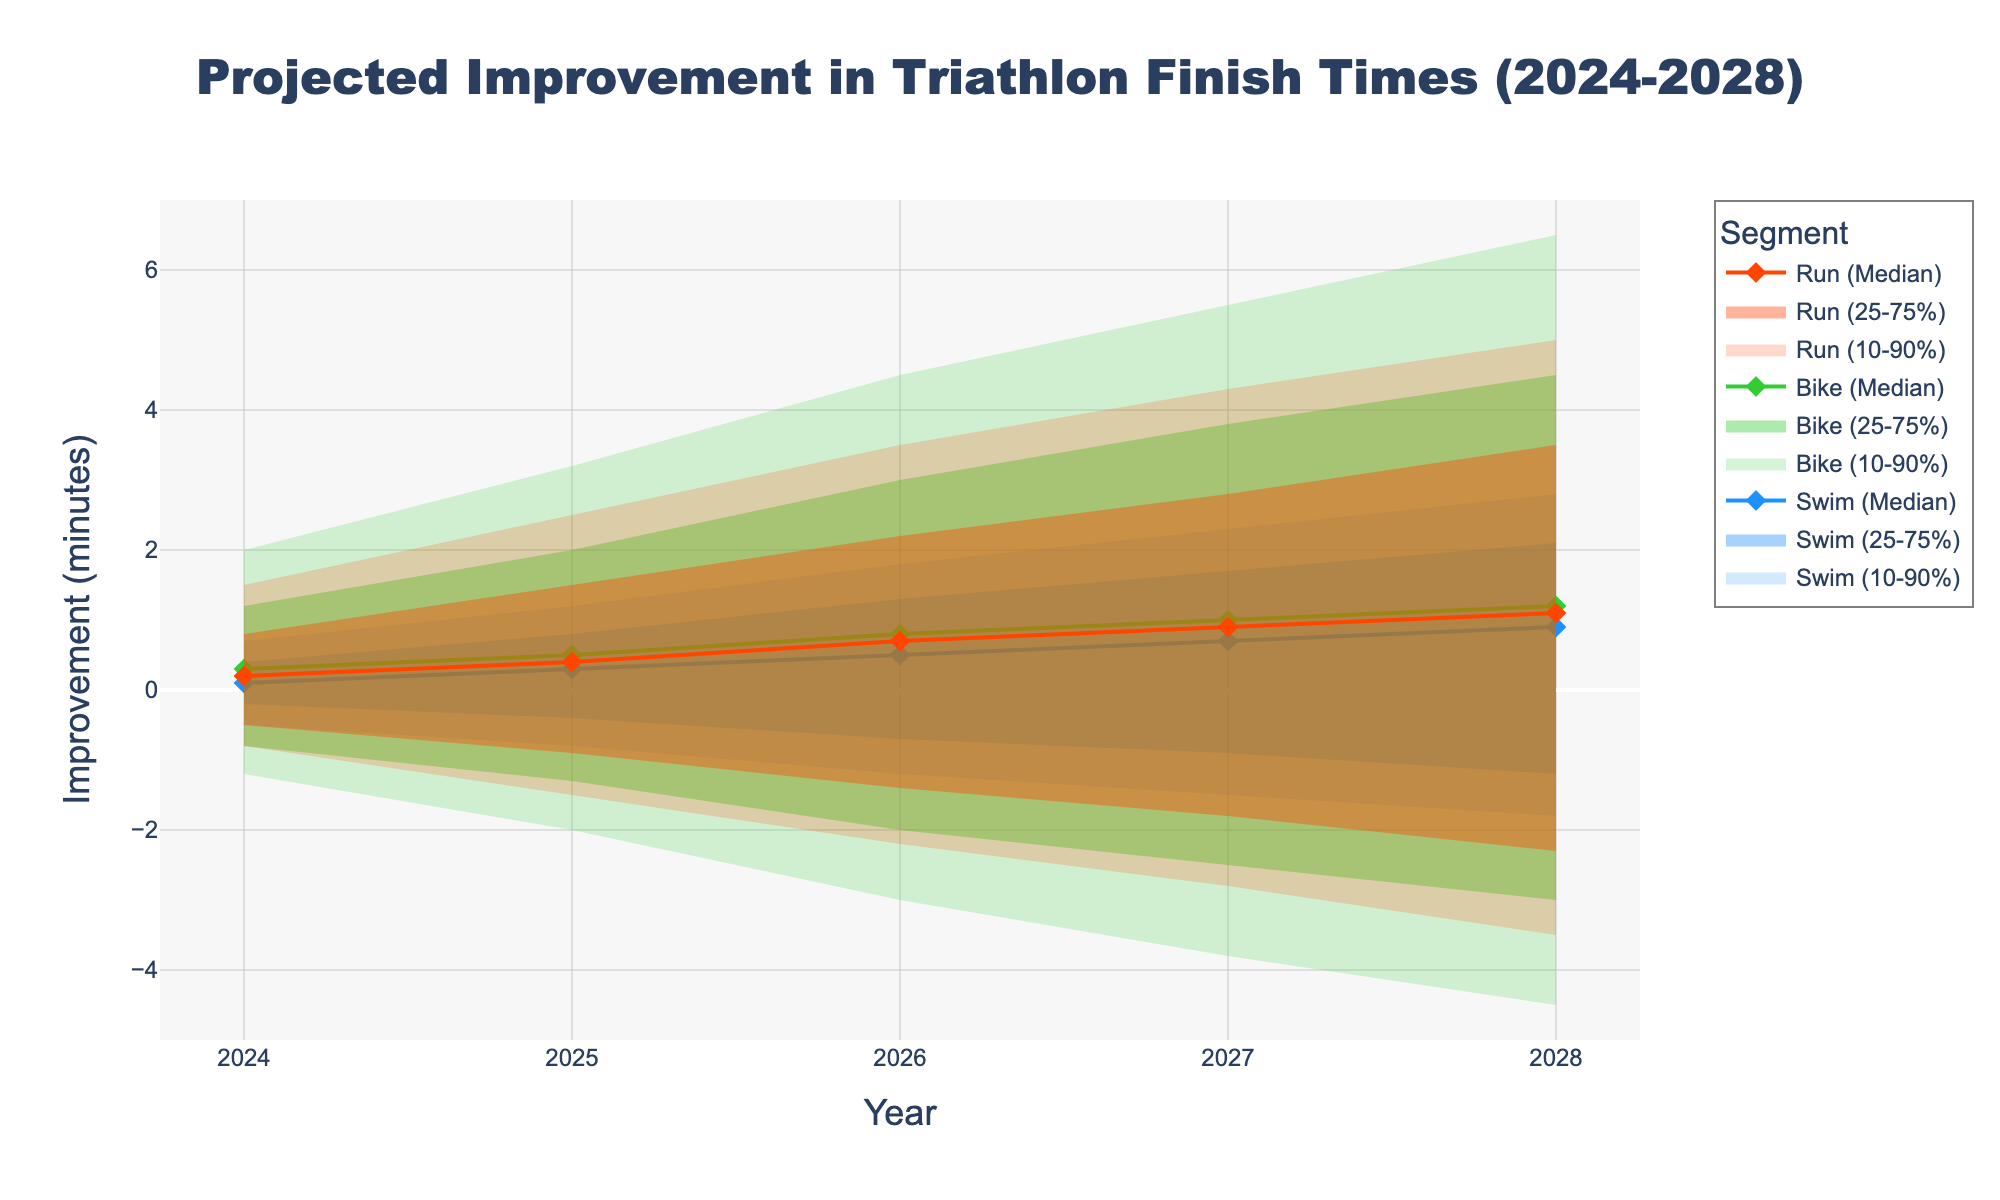What is the title of the figure? The title is displayed prominently at the top of the chart. It is usually in a larger font size compared to other text elements.
Answer: Projected Improvement in Triathlon Finish Times (2024-2028) What does the y-axis represent? The y-axis typically indicates the type of measurement being displayed. The figure usually has axis labels to make it clear.
Answer: Improvement (minutes) Which segment is predicted to have the most improvement in the median value by 2028? To find the segment with the most improvement, compare the median values for all segments in 2028.
Answer: Bike How consistent is the projected median improvement in the swim segment over the five years? Evaluate the median values for the swim segment from 2024 to 2028 and see if they change significantly.
Answer: It increases gradually from 0.1 to 0.9 minutes In 2026, what is the 10th-to-90th percentile range for the bike segment? The range is found by subtracting the 10th percentile value from the 90th percentile value for the bike segment in 2026.
Answer: 7.5 minutes Which year shows the largest range in the 25th-to-75th percentiles for the run segment? Determine the range for each year by subtracting the 25th percentile value from the 75th percentile value and see which year has the highest difference.
Answer: 2028 How do the 75th percentile values for the swim segment change over time from 2024 to 2028? Look at the 75th percentile values for the swim segment each year from 2024 to 2028 and describe the trend.
Answer: They increase from 0.4 to 2.1 minutes In 2025, which segment has the highest median improvement? Identify and compare the median values for all segments for the year 2025.
Answer: Bike Which segment shows the most significant improvement between the 25th and 75th percentiles by 2028 compared to 2024? Calculate the difference between the 25th and 75th percentiles for each segment in 2024 and 2028, then identify the segment with the largest increase.
Answer: Bike Between 2024 and 2028, which segment's median improvement value does not change direction (always increases or always decreases)? Examine the median values year by year for each segment and see if they consistently move in one direction.
Answer: Swim 